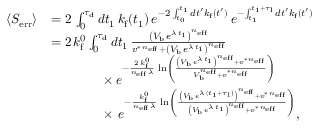<formula> <loc_0><loc_0><loc_500><loc_500>\begin{array} { r l } { \langle S _ { e r r } \rangle } & { = 2 \, \int _ { 0 } ^ { \tau _ { d } } d t _ { 1 } \, k _ { f } ( t _ { 1 } ) \, e ^ { - 2 \, \int _ { t _ { 0 } } ^ { t _ { 1 } } d t ^ { \prime } k _ { f } ( t ^ { \prime } ) } \, e ^ { - \int _ { t _ { 1 } } ^ { t _ { 1 } + \tau _ { l } } d t ^ { \prime } k _ { f } ( t ^ { \prime } ) } } \\ & { = 2 \, k _ { f } ^ { 0 } \int _ { 0 } ^ { \tau _ { d } } d t _ { 1 } \, \frac { \left ( V _ { b } \, e ^ { \lambda \, t _ { 1 } } \right ) ^ { n _ { e f f } } } { v ^ { \ast \, n _ { e f f } } + \left ( V _ { b } \, e ^ { \lambda \, t _ { 1 } } \right ) ^ { n _ { e f f } } } } \\ & { \quad \times \, e ^ { - \frac { 2 \, k _ { f } ^ { 0 } } { n _ { e f f } \, \lambda } \, \ln \left ( \frac { \left ( V _ { b } \, e ^ { \lambda \, t _ { 1 } } \right ) ^ { n _ { e f f } } + v ^ { \ast \, n _ { e f f } } } { V _ { b } ^ { n _ { e f f } } + v ^ { \ast \, n _ { e f f } } } \right ) } } \\ & { \quad \times \, e ^ { - \frac { k _ { f } ^ { 0 } } { n _ { e f f } \, \lambda } \, \ln \left ( \frac { \left ( V _ { b } \, e ^ { \lambda \, ( t _ { 1 } + \tau _ { l } ) } \right ) ^ { n _ { e f f } } + v ^ { \ast \, n _ { e f f } } } { \left ( V _ { b } \, e ^ { \lambda \, t _ { 1 } } \right ) ^ { n _ { e f f } } + v ^ { \ast \, n _ { e f f } } } \right ) } , } \end{array}</formula> 